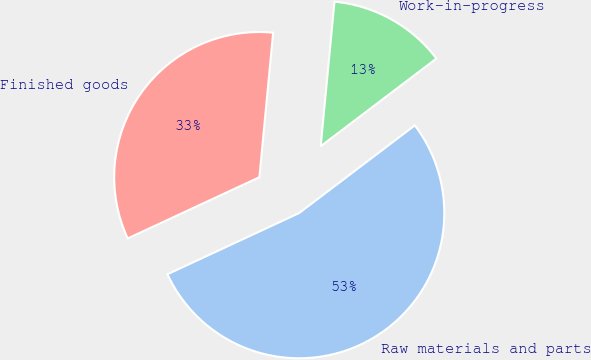Convert chart to OTSL. <chart><loc_0><loc_0><loc_500><loc_500><pie_chart><fcel>Raw materials and parts<fcel>Work-in-progress<fcel>Finished goods<nl><fcel>53.4%<fcel>13.17%<fcel>33.44%<nl></chart> 